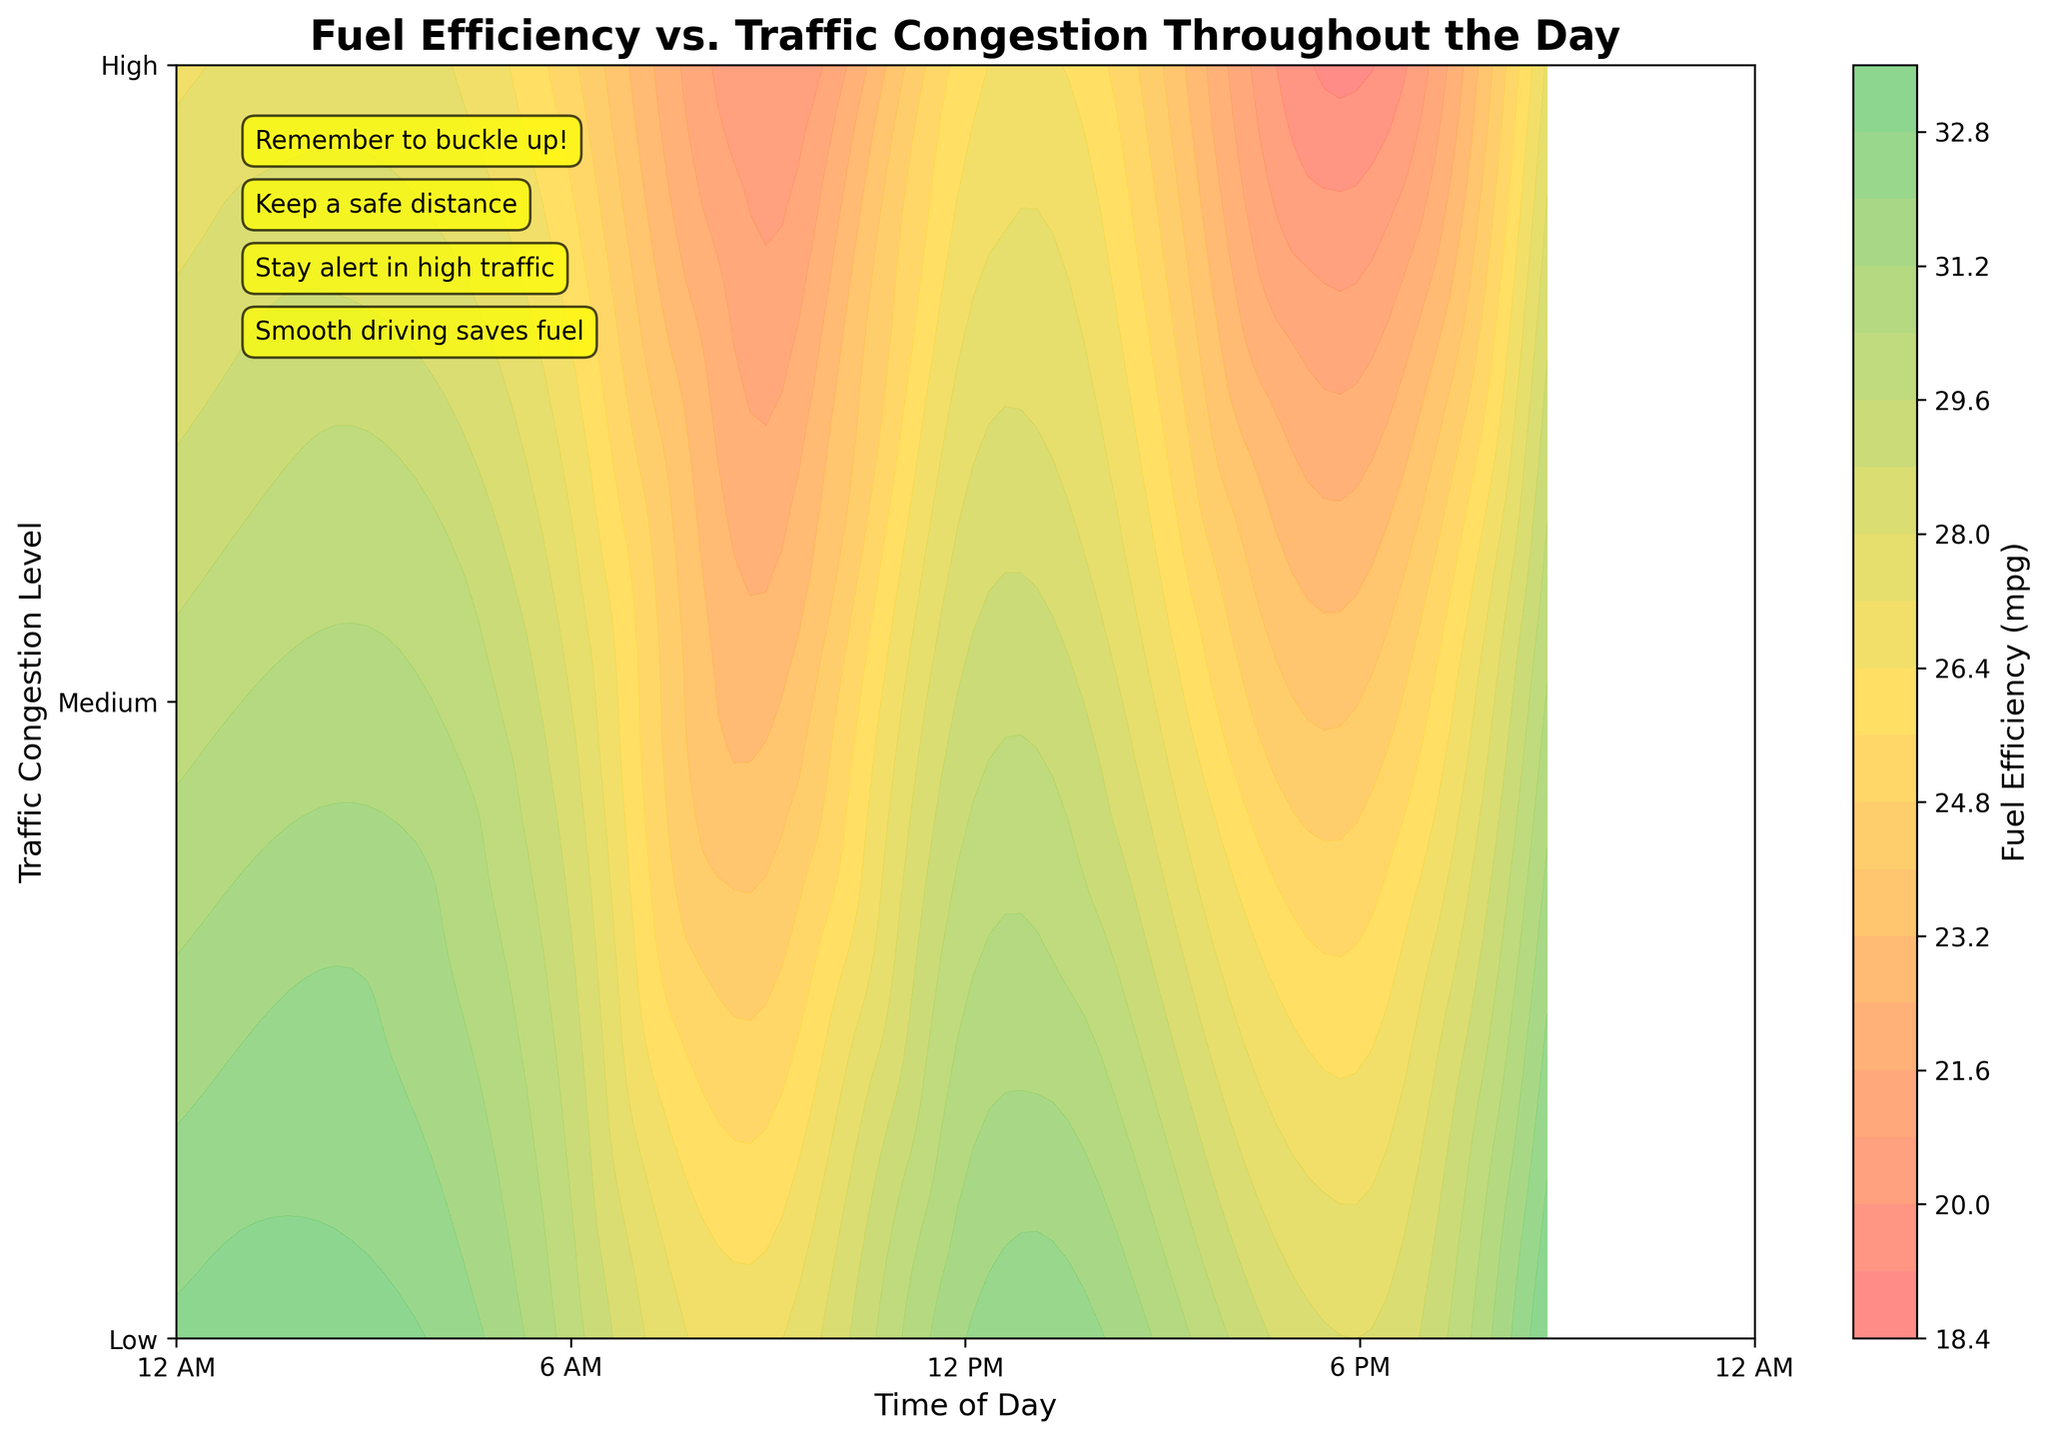What is the title of the figure? The title is typically placed at the top of the figure, in a larger font size. It reads: "Fuel Efficiency vs. Traffic Congestion Throughout the Day".
Answer: Fuel Efficiency vs. Traffic Congestion Throughout the Day What does the color bar represent? The color bar provides information about what the different colors on the plot signify. It represents "Fuel Efficiency (mpg)".
Answer: Fuel Efficiency (mpg) Which time of day appears to have the highest fuel efficiency under low traffic congestion? The color that indicates the highest fuel efficiency is found at 9:00 PM on the plot, under "Low" on the y-axis, as it corresponds to the darkest green area.
Answer: 9:00 PM When is fuel efficiency the lowest during high traffic congestion? Observing the darkest red area under "High" on the y-axis, it is 6:00 PM on the x-axis where the fuel efficiency is lowest.
Answer: 6:00 PM How does fuel efficiency generally change with increasing traffic congestion levels? The contour plot shows a gradient where greens (high efficiency) turn to reds (low efficiency) as we move from "Low" to "High" traffic congestion across all times of the day. This indicates fuel efficiency decreases with higher congestion.
Answer: It decreases Compare fuel efficiency at 6:00 AM and 6:00 PM under medium traffic congestion. At 6:00 AM under medium congestion (1 on the y-axis), the fuel efficiency is around 28 mpg (yellowish area). At 6:00 PM under medium congestion, the fuel efficiency is about 24 mpg (orangish area).
Answer: Higher at 6:00 AM What can be inferred about the safest time to drive based on fuel efficiency and traffic congestion? Based on the figure, 9:00 PM shows higher fuel efficiency under both low and medium congestion levels, suggesting less traffic and likely safer driving conditions. Observing the annotations for safety tips reinforces evening or night-time driving as safer.
Answer: 9:00 PM During which time blocks does fuel efficiency remain consistently high across low congestion levels? The green areas along the y-axis at "Low" traffic congestion are prominent at 12:00 PM, 9:00 PM, and 12:00 AM, indicating high fuel efficiency.
Answer: 12:00 PM, 9:00 PM, 12:00 AM Analyze the general trend of fuel efficiency from early morning to midnight. Starting from early morning (6:00 AM), there is a mix of low to medium efficiency colors which improve slightly towards mid-morning to noon (mix of yellows and greens). Moving towards late afternoon and early evening (3:00 PM to 6:00 PM), efficiency drops significantly (oranges and reds). Late evening (9:00 PM to 12:00 AM) sees fuel efficiency improve again (greens). This indicates fuel efficiency is generally better during noon to early afternoon and late evening to midnight.
Answer: Improves then drops and improves again Can you point out any outlier in the fuel efficiency pattern for high traffic congestion? Generally, fuel efficiency is low under high congestion, but at 12:00 AM it is slightly better (observing the contour lines suggests it's more yellowish compared to oranges and reds at other times under "High").
Answer: 12:00 AM 